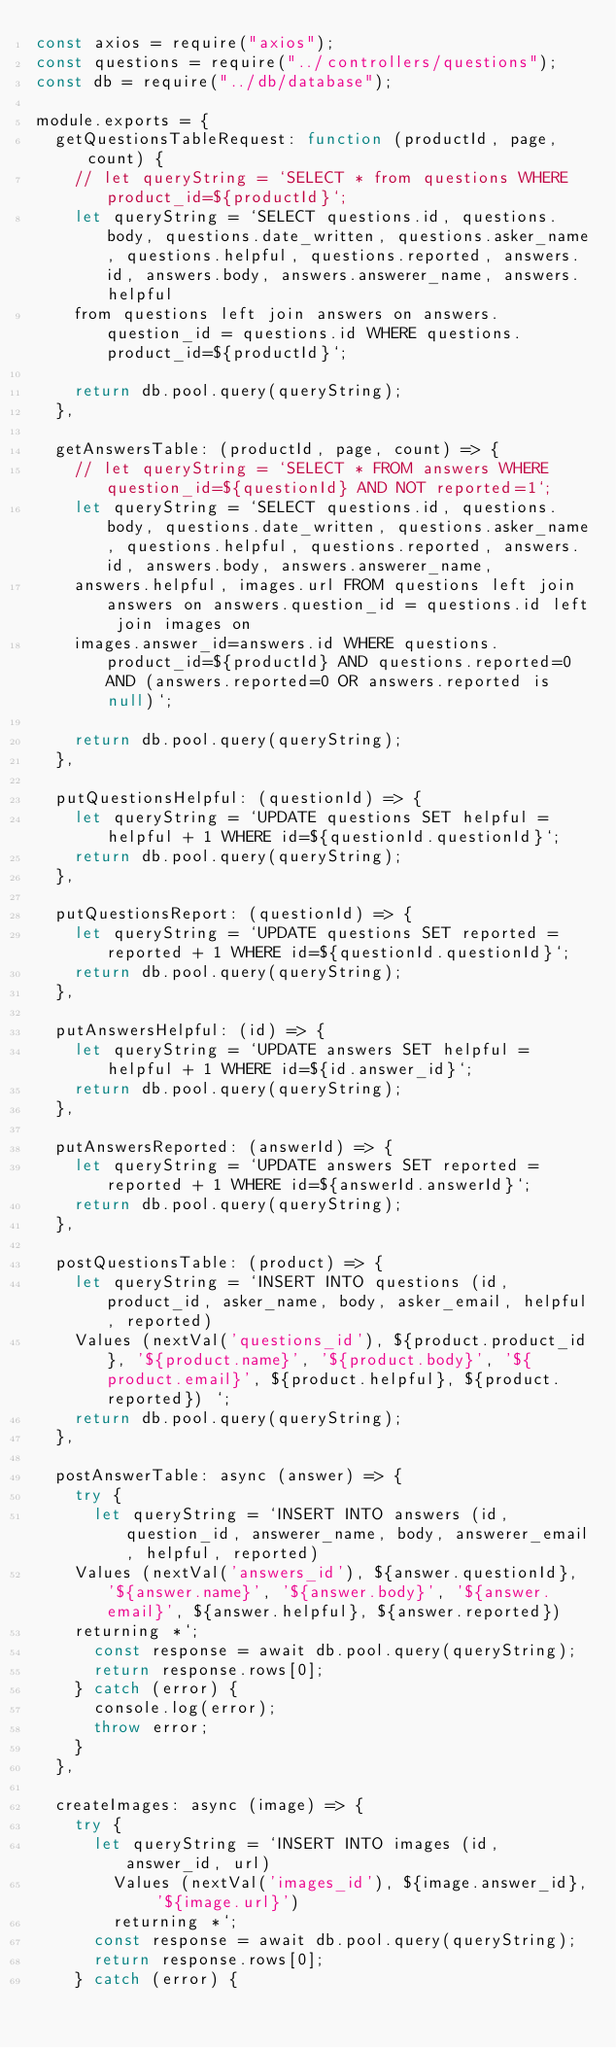<code> <loc_0><loc_0><loc_500><loc_500><_JavaScript_>const axios = require("axios");
const questions = require("../controllers/questions");
const db = require("../db/database");

module.exports = {
  getQuestionsTableRequest: function (productId, page, count) {
    // let queryString = `SELECT * from questions WHERE product_id=${productId}`;
    let queryString = `SELECT questions.id, questions.body, questions.date_written, questions.asker_name, questions.helpful, questions.reported, answers.id, answers.body, answers.answerer_name, answers.helpful 
    from questions left join answers on answers.question_id = questions.id WHERE questions.product_id=${productId}`;

    return db.pool.query(queryString);
  },

  getAnswersTable: (productId, page, count) => {
    // let queryString = `SELECT * FROM answers WHERE question_id=${questionId} AND NOT reported=1`;
    let queryString = `SELECT questions.id, questions.body, questions.date_written, questions.asker_name, questions.helpful, questions.reported, answers.id, answers.body, answers.answerer_name,
    answers.helpful, images.url FROM questions left join answers on answers.question_id = questions.id left join images on 
    images.answer_id=answers.id WHERE questions.product_id=${productId} AND questions.reported=0 AND (answers.reported=0 OR answers.reported is null)`;

    return db.pool.query(queryString);
  },

  putQuestionsHelpful: (questionId) => {
    let queryString = `UPDATE questions SET helpful = helpful + 1 WHERE id=${questionId.questionId}`;
    return db.pool.query(queryString);
  },

  putQuestionsReport: (questionId) => {
    let queryString = `UPDATE questions SET reported = reported + 1 WHERE id=${questionId.questionId}`;
    return db.pool.query(queryString);
  },

  putAnswersHelpful: (id) => {
    let queryString = `UPDATE answers SET helpful = helpful + 1 WHERE id=${id.answer_id}`;
    return db.pool.query(queryString);
  },

  putAnswersReported: (answerId) => {
    let queryString = `UPDATE answers SET reported = reported + 1 WHERE id=${answerId.answerId}`;
    return db.pool.query(queryString);
  },

  postQuestionsTable: (product) => {
    let queryString = `INSERT INTO questions (id, product_id, asker_name, body, asker_email, helpful, reported)
    Values (nextVal('questions_id'), ${product.product_id}, '${product.name}', '${product.body}', '${product.email}', ${product.helpful}, ${product.reported}) `;
    return db.pool.query(queryString);
  },

  postAnswerTable: async (answer) => {
    try {
      let queryString = `INSERT INTO answers (id, question_id, answerer_name, body, answerer_email, helpful, reported)
    Values (nextVal('answers_id'), ${answer.questionId}, '${answer.name}', '${answer.body}', '${answer.email}', ${answer.helpful}, ${answer.reported})
    returning *`;
      const response = await db.pool.query(queryString);
      return response.rows[0];
    } catch (error) {
      console.log(error);
      throw error;
    }
  },

  createImages: async (image) => {
    try {
      let queryString = `INSERT INTO images (id, answer_id, url)
        Values (nextVal('images_id'), ${image.answer_id}, '${image.url}')
        returning *`;
      const response = await db.pool.query(queryString);
      return response.rows[0];
    } catch (error) {</code> 